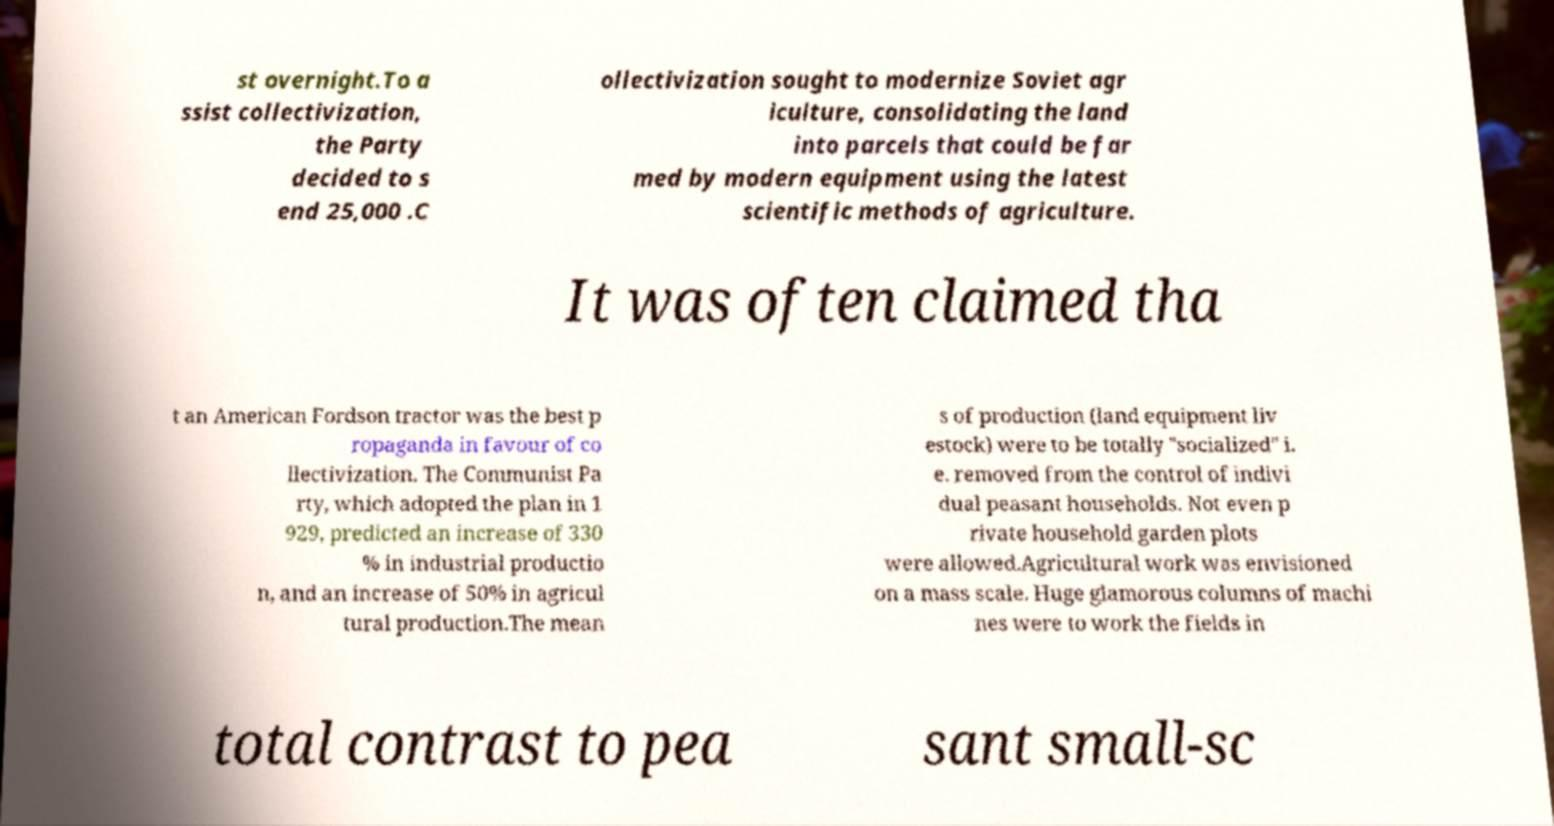Please identify and transcribe the text found in this image. st overnight.To a ssist collectivization, the Party decided to s end 25,000 .C ollectivization sought to modernize Soviet agr iculture, consolidating the land into parcels that could be far med by modern equipment using the latest scientific methods of agriculture. It was often claimed tha t an American Fordson tractor was the best p ropaganda in favour of co llectivization. The Communist Pa rty, which adopted the plan in 1 929, predicted an increase of 330 % in industrial productio n, and an increase of 50% in agricul tural production.The mean s of production (land equipment liv estock) were to be totally "socialized" i. e. removed from the control of indivi dual peasant households. Not even p rivate household garden plots were allowed.Agricultural work was envisioned on a mass scale. Huge glamorous columns of machi nes were to work the fields in total contrast to pea sant small-sc 